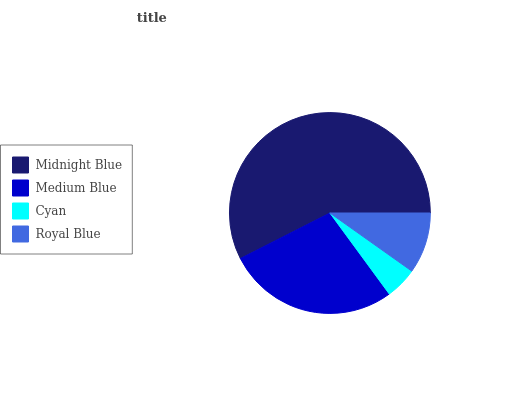Is Cyan the minimum?
Answer yes or no. Yes. Is Midnight Blue the maximum?
Answer yes or no. Yes. Is Medium Blue the minimum?
Answer yes or no. No. Is Medium Blue the maximum?
Answer yes or no. No. Is Midnight Blue greater than Medium Blue?
Answer yes or no. Yes. Is Medium Blue less than Midnight Blue?
Answer yes or no. Yes. Is Medium Blue greater than Midnight Blue?
Answer yes or no. No. Is Midnight Blue less than Medium Blue?
Answer yes or no. No. Is Medium Blue the high median?
Answer yes or no. Yes. Is Royal Blue the low median?
Answer yes or no. Yes. Is Cyan the high median?
Answer yes or no. No. Is Midnight Blue the low median?
Answer yes or no. No. 